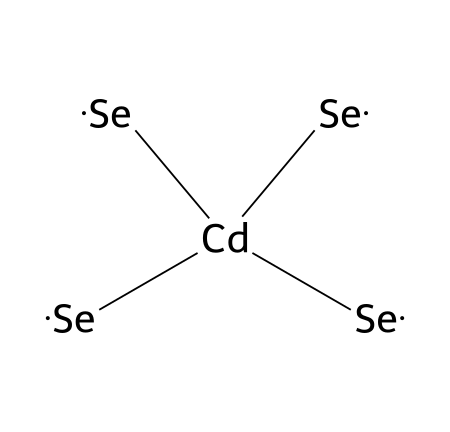What is the central atom in this quantum dot structure? The provided SMILES representation shows cadmium [Cd] as the central atom bonded to four selenium atoms [Se]. Therefore, cadmium is identified as the central atom in the chemical structure.
Answer: cadmium How many selenium atoms are present? By analyzing the SMILES representation, there are four instances of selenium atoms [Se] connected to the central cadmium atom. Thus, the total number of selenium atoms is four.
Answer: four What is the total number of atoms in this chemical structure? The structure consists of one cadmium atom and four selenium atoms. Counting these gives a total of five atoms in the chemical formula.
Answer: five What type of bonding exists between cadmium and selenium? The SMILES notation indicates that the cadmium atom is connected to selenium atoms through single bonds, as there are no indications of multiple bonds shown in the representation.
Answer: single bonds What is the likely application of cadmium selenide quantum dots? Cadmium selenide quantum dots are primarily used in display technologies, such as QLED displays, due to their ability to emit specific colors when excited.
Answer: display technologies Why are quantum dots considered semiconductors? Quantum dots, including cadmium selenide, possess properties of semiconductors due to the presence of a central metal atom and chalcogenides like selenium, which allow them to control electron movement and energy levels effectively.
Answer: semiconductors What color of light do cadmium selenide quantum dots typically emit? The emission color of cadmium selenide quantum dots is primarily determined by their size, often ranging from red to green light depending on the dot size and quantum confinement effects.
Answer: red to green 